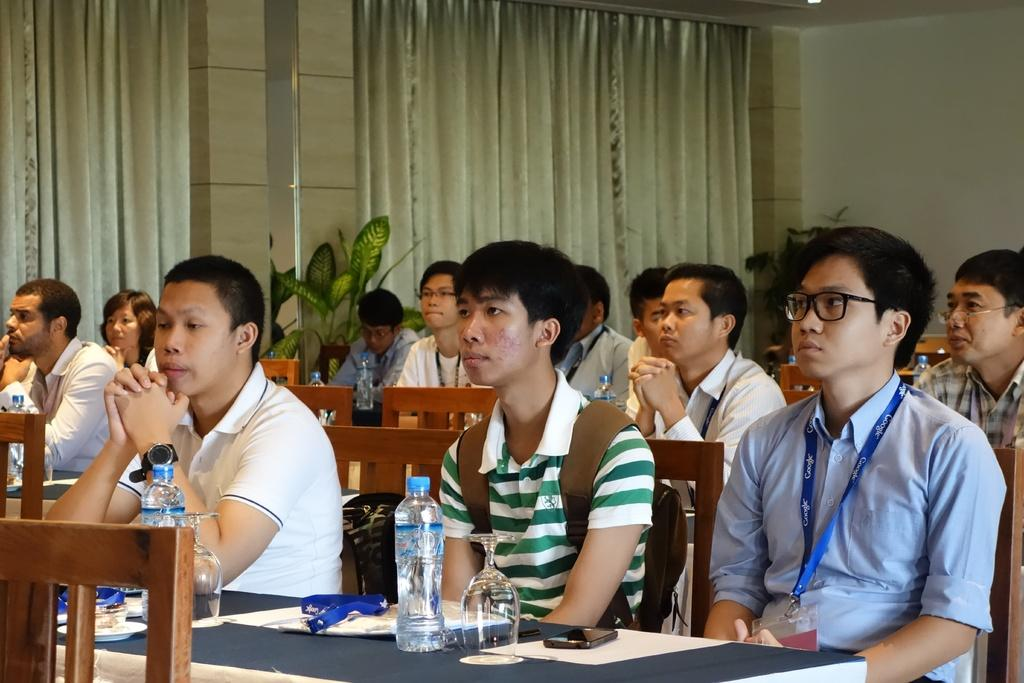How many people are in the image? There is a group of people in the image. What are the people doing in the image? The people are sitting on chairs. What is on the tables in front of the chairs? Glasses and bottles of water are present on the tables. What type of vegetation can be seen in the image? There are plants in the image. What type of window treatment is present in the image? Curtains are present in the image. What type of bedroom furniture can be seen in the image? There is no bedroom furniture present in the image. Who is taking care of the plants in the image? The image does not provide information about who is taking care of the plants. 